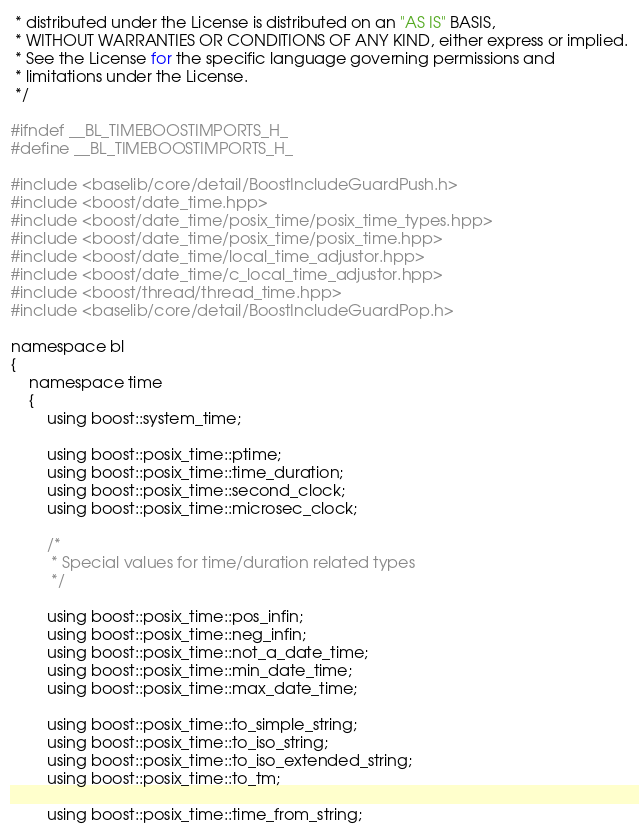<code> <loc_0><loc_0><loc_500><loc_500><_C_> * distributed under the License is distributed on an "AS IS" BASIS,
 * WITHOUT WARRANTIES OR CONDITIONS OF ANY KIND, either express or implied.
 * See the License for the specific language governing permissions and
 * limitations under the License.
 */

#ifndef __BL_TIMEBOOSTIMPORTS_H_
#define __BL_TIMEBOOSTIMPORTS_H_

#include <baselib/core/detail/BoostIncludeGuardPush.h>
#include <boost/date_time.hpp>
#include <boost/date_time/posix_time/posix_time_types.hpp>
#include <boost/date_time/posix_time/posix_time.hpp>
#include <boost/date_time/local_time_adjustor.hpp>
#include <boost/date_time/c_local_time_adjustor.hpp>
#include <boost/thread/thread_time.hpp>
#include <baselib/core/detail/BoostIncludeGuardPop.h>

namespace bl
{
    namespace time
    {
        using boost::system_time;

        using boost::posix_time::ptime;
        using boost::posix_time::time_duration;
        using boost::posix_time::second_clock;
        using boost::posix_time::microsec_clock;

        /*
         * Special values for time/duration related types
         */

        using boost::posix_time::pos_infin;
        using boost::posix_time::neg_infin;
        using boost::posix_time::not_a_date_time;
        using boost::posix_time::min_date_time;
        using boost::posix_time::max_date_time;

        using boost::posix_time::to_simple_string;
        using boost::posix_time::to_iso_string;
        using boost::posix_time::to_iso_extended_string;
        using boost::posix_time::to_tm;

        using boost::posix_time::time_from_string;</code> 